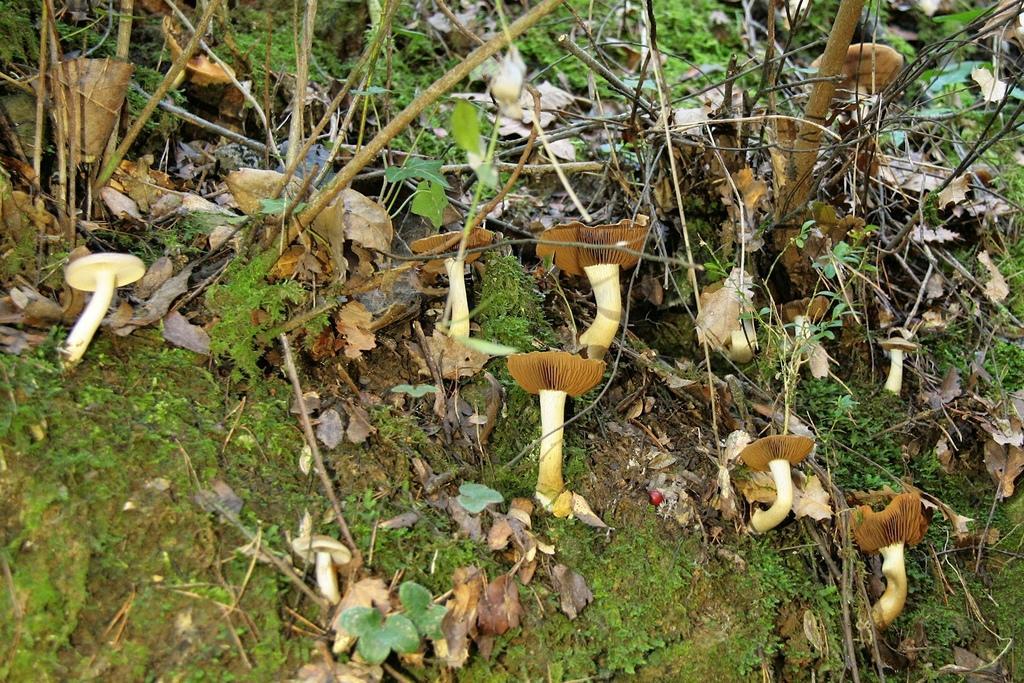In one or two sentences, can you explain what this image depicts? In this picture I can see mushrooms, leaves and branches. 